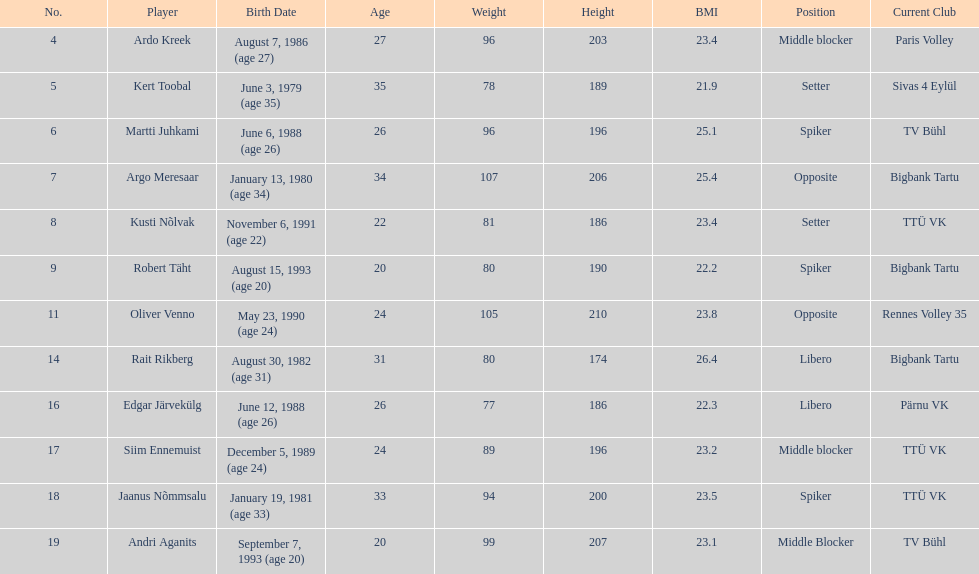Which players played the same position as ardo kreek? Siim Ennemuist, Andri Aganits. Could you help me parse every detail presented in this table? {'header': ['No.', 'Player', 'Birth Date', 'Age', 'Weight', 'Height', 'BMI', 'Position', 'Current Club'], 'rows': [['4', 'Ardo Kreek', 'August 7, 1986 (age\xa027)', '27', '96', '203', '23.4', 'Middle blocker', 'Paris Volley'], ['5', 'Kert Toobal', 'June 3, 1979 (age\xa035)', '35', '78', '189', '21.9', 'Setter', 'Sivas 4 Eylül'], ['6', 'Martti Juhkami', 'June 6, 1988 (age\xa026)', '26', '96', '196', '25.1', 'Spiker', 'TV Bühl'], ['7', 'Argo Meresaar', 'January 13, 1980 (age\xa034)', '34', '107', '206', '25.4', 'Opposite', 'Bigbank Tartu'], ['8', 'Kusti Nõlvak', 'November 6, 1991 (age\xa022)', '22', '81', '186', '23.4', 'Setter', 'TTÜ VK'], ['9', 'Robert Täht', 'August 15, 1993 (age\xa020)', '20', '80', '190', '22.2', 'Spiker', 'Bigbank Tartu'], ['11', 'Oliver Venno', 'May 23, 1990 (age\xa024)', '24', '105', '210', '23.8', 'Opposite', 'Rennes Volley 35'], ['14', 'Rait Rikberg', 'August 30, 1982 (age\xa031)', '31', '80', '174', '26.4', 'Libero', 'Bigbank Tartu'], ['16', 'Edgar Järvekülg', 'June 12, 1988 (age\xa026)', '26', '77', '186', '22.3', 'Libero', 'Pärnu VK'], ['17', 'Siim Ennemuist', 'December 5, 1989 (age\xa024)', '24', '89', '196', '23.2', 'Middle blocker', 'TTÜ VK'], ['18', 'Jaanus Nõmmsalu', 'January 19, 1981 (age\xa033)', '33', '94', '200', '23.5', 'Spiker', 'TTÜ VK'], ['19', 'Andri Aganits', 'September 7, 1993 (age\xa020)', '20', '99', '207', '23.1', 'Middle Blocker', 'TV Bühl']]} 